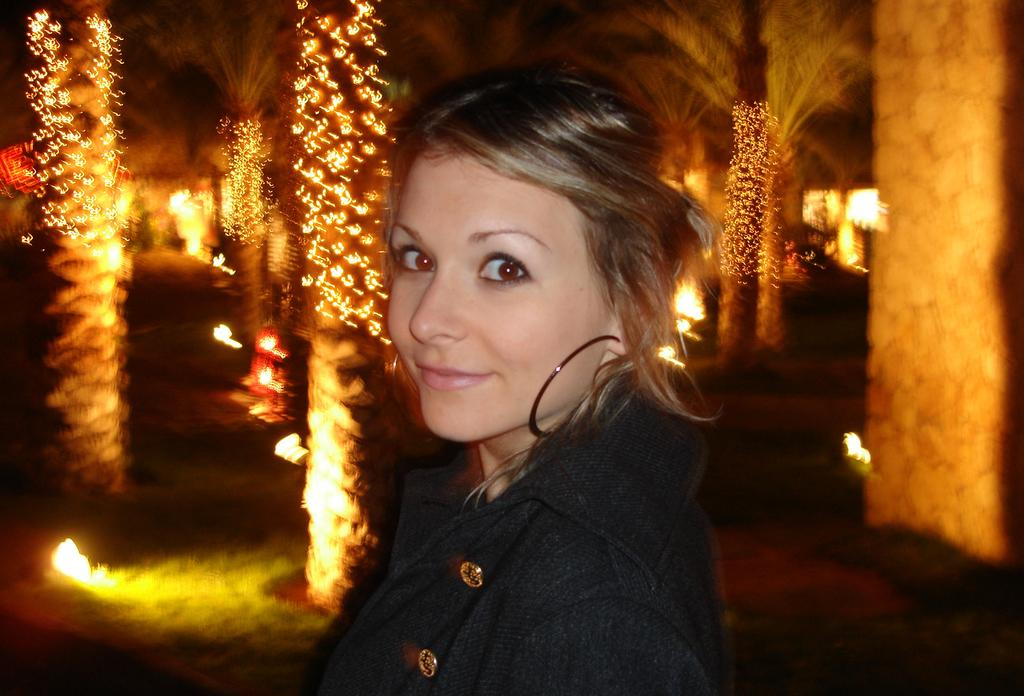Who is present in the image? There is a woman in the image. What is the woman's expression? The woman is smiling. What can be seen in the background of the image? There are lights, trees, and some objects in the background of the image. What type of desk can be seen in the image? There is no desk present in the image. How does the woman express hate towards the bushes in the image? The image does not show the woman expressing hate towards any bushes, as there are no bushes present in the image. 